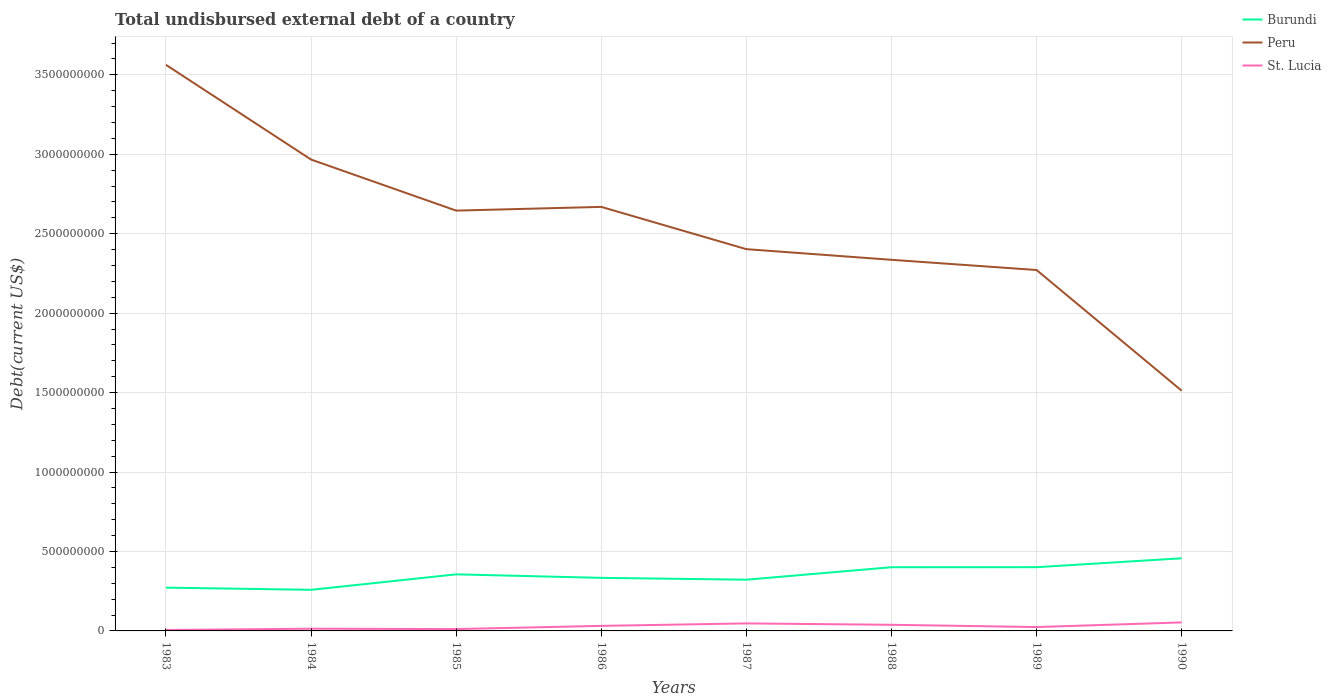How many different coloured lines are there?
Offer a very short reply. 3. Does the line corresponding to Peru intersect with the line corresponding to St. Lucia?
Your answer should be very brief. No. Across all years, what is the maximum total undisbursed external debt in Peru?
Give a very brief answer. 1.51e+09. What is the total total undisbursed external debt in Peru in the graph?
Offer a very short reply. 3.33e+08. What is the difference between the highest and the second highest total undisbursed external debt in St. Lucia?
Provide a short and direct response. 4.74e+07. How many lines are there?
Your response must be concise. 3. How many years are there in the graph?
Your answer should be compact. 8. Does the graph contain grids?
Offer a very short reply. Yes. Where does the legend appear in the graph?
Make the answer very short. Top right. What is the title of the graph?
Offer a very short reply. Total undisbursed external debt of a country. What is the label or title of the X-axis?
Provide a short and direct response. Years. What is the label or title of the Y-axis?
Ensure brevity in your answer.  Debt(current US$). What is the Debt(current US$) in Burundi in 1983?
Provide a short and direct response. 2.72e+08. What is the Debt(current US$) of Peru in 1983?
Your answer should be compact. 3.56e+09. What is the Debt(current US$) in St. Lucia in 1983?
Provide a succinct answer. 6.08e+06. What is the Debt(current US$) of Burundi in 1984?
Your answer should be very brief. 2.59e+08. What is the Debt(current US$) of Peru in 1984?
Give a very brief answer. 2.97e+09. What is the Debt(current US$) of St. Lucia in 1984?
Your answer should be very brief. 1.39e+07. What is the Debt(current US$) of Burundi in 1985?
Give a very brief answer. 3.56e+08. What is the Debt(current US$) in Peru in 1985?
Your response must be concise. 2.65e+09. What is the Debt(current US$) of St. Lucia in 1985?
Provide a short and direct response. 1.16e+07. What is the Debt(current US$) of Burundi in 1986?
Provide a succinct answer. 3.34e+08. What is the Debt(current US$) in Peru in 1986?
Keep it short and to the point. 2.67e+09. What is the Debt(current US$) of St. Lucia in 1986?
Keep it short and to the point. 3.18e+07. What is the Debt(current US$) in Burundi in 1987?
Offer a very short reply. 3.22e+08. What is the Debt(current US$) of Peru in 1987?
Your response must be concise. 2.40e+09. What is the Debt(current US$) of St. Lucia in 1987?
Offer a very short reply. 4.73e+07. What is the Debt(current US$) of Burundi in 1988?
Offer a terse response. 4.01e+08. What is the Debt(current US$) in Peru in 1988?
Your response must be concise. 2.34e+09. What is the Debt(current US$) in St. Lucia in 1988?
Your response must be concise. 3.86e+07. What is the Debt(current US$) of Burundi in 1989?
Provide a short and direct response. 4.01e+08. What is the Debt(current US$) of Peru in 1989?
Give a very brief answer. 2.27e+09. What is the Debt(current US$) in St. Lucia in 1989?
Your answer should be very brief. 2.44e+07. What is the Debt(current US$) of Burundi in 1990?
Make the answer very short. 4.57e+08. What is the Debt(current US$) of Peru in 1990?
Your answer should be compact. 1.51e+09. What is the Debt(current US$) of St. Lucia in 1990?
Give a very brief answer. 5.35e+07. Across all years, what is the maximum Debt(current US$) in Burundi?
Offer a very short reply. 4.57e+08. Across all years, what is the maximum Debt(current US$) of Peru?
Provide a succinct answer. 3.56e+09. Across all years, what is the maximum Debt(current US$) in St. Lucia?
Keep it short and to the point. 5.35e+07. Across all years, what is the minimum Debt(current US$) in Burundi?
Provide a short and direct response. 2.59e+08. Across all years, what is the minimum Debt(current US$) in Peru?
Provide a succinct answer. 1.51e+09. Across all years, what is the minimum Debt(current US$) in St. Lucia?
Your answer should be compact. 6.08e+06. What is the total Debt(current US$) in Burundi in the graph?
Keep it short and to the point. 2.80e+09. What is the total Debt(current US$) of Peru in the graph?
Ensure brevity in your answer.  2.04e+1. What is the total Debt(current US$) in St. Lucia in the graph?
Make the answer very short. 2.27e+08. What is the difference between the Debt(current US$) in Burundi in 1983 and that in 1984?
Make the answer very short. 1.37e+07. What is the difference between the Debt(current US$) in Peru in 1983 and that in 1984?
Offer a very short reply. 5.96e+08. What is the difference between the Debt(current US$) of St. Lucia in 1983 and that in 1984?
Your response must be concise. -7.85e+06. What is the difference between the Debt(current US$) of Burundi in 1983 and that in 1985?
Your answer should be compact. -8.36e+07. What is the difference between the Debt(current US$) of Peru in 1983 and that in 1985?
Ensure brevity in your answer.  9.18e+08. What is the difference between the Debt(current US$) in St. Lucia in 1983 and that in 1985?
Make the answer very short. -5.56e+06. What is the difference between the Debt(current US$) in Burundi in 1983 and that in 1986?
Your answer should be very brief. -6.16e+07. What is the difference between the Debt(current US$) in Peru in 1983 and that in 1986?
Ensure brevity in your answer.  8.94e+08. What is the difference between the Debt(current US$) of St. Lucia in 1983 and that in 1986?
Your response must be concise. -2.57e+07. What is the difference between the Debt(current US$) of Burundi in 1983 and that in 1987?
Offer a very short reply. -5.00e+07. What is the difference between the Debt(current US$) of Peru in 1983 and that in 1987?
Give a very brief answer. 1.16e+09. What is the difference between the Debt(current US$) in St. Lucia in 1983 and that in 1987?
Offer a very short reply. -4.12e+07. What is the difference between the Debt(current US$) in Burundi in 1983 and that in 1988?
Your answer should be very brief. -1.28e+08. What is the difference between the Debt(current US$) of Peru in 1983 and that in 1988?
Your answer should be very brief. 1.23e+09. What is the difference between the Debt(current US$) in St. Lucia in 1983 and that in 1988?
Ensure brevity in your answer.  -3.25e+07. What is the difference between the Debt(current US$) in Burundi in 1983 and that in 1989?
Offer a very short reply. -1.29e+08. What is the difference between the Debt(current US$) of Peru in 1983 and that in 1989?
Your response must be concise. 1.29e+09. What is the difference between the Debt(current US$) of St. Lucia in 1983 and that in 1989?
Make the answer very short. -1.83e+07. What is the difference between the Debt(current US$) in Burundi in 1983 and that in 1990?
Your answer should be compact. -1.85e+08. What is the difference between the Debt(current US$) in Peru in 1983 and that in 1990?
Provide a succinct answer. 2.05e+09. What is the difference between the Debt(current US$) in St. Lucia in 1983 and that in 1990?
Offer a very short reply. -4.74e+07. What is the difference between the Debt(current US$) of Burundi in 1984 and that in 1985?
Provide a short and direct response. -9.73e+07. What is the difference between the Debt(current US$) of Peru in 1984 and that in 1985?
Offer a terse response. 3.21e+08. What is the difference between the Debt(current US$) of St. Lucia in 1984 and that in 1985?
Provide a short and direct response. 2.29e+06. What is the difference between the Debt(current US$) in Burundi in 1984 and that in 1986?
Give a very brief answer. -7.53e+07. What is the difference between the Debt(current US$) in Peru in 1984 and that in 1986?
Offer a terse response. 2.98e+08. What is the difference between the Debt(current US$) in St. Lucia in 1984 and that in 1986?
Ensure brevity in your answer.  -1.79e+07. What is the difference between the Debt(current US$) of Burundi in 1984 and that in 1987?
Offer a very short reply. -6.37e+07. What is the difference between the Debt(current US$) of Peru in 1984 and that in 1987?
Give a very brief answer. 5.64e+08. What is the difference between the Debt(current US$) in St. Lucia in 1984 and that in 1987?
Make the answer very short. -3.34e+07. What is the difference between the Debt(current US$) in Burundi in 1984 and that in 1988?
Offer a terse response. -1.42e+08. What is the difference between the Debt(current US$) in Peru in 1984 and that in 1988?
Provide a short and direct response. 6.31e+08. What is the difference between the Debt(current US$) of St. Lucia in 1984 and that in 1988?
Keep it short and to the point. -2.46e+07. What is the difference between the Debt(current US$) in Burundi in 1984 and that in 1989?
Your answer should be compact. -1.42e+08. What is the difference between the Debt(current US$) in Peru in 1984 and that in 1989?
Offer a terse response. 6.95e+08. What is the difference between the Debt(current US$) of St. Lucia in 1984 and that in 1989?
Offer a very short reply. -1.04e+07. What is the difference between the Debt(current US$) in Burundi in 1984 and that in 1990?
Make the answer very short. -1.98e+08. What is the difference between the Debt(current US$) in Peru in 1984 and that in 1990?
Your answer should be very brief. 1.45e+09. What is the difference between the Debt(current US$) of St. Lucia in 1984 and that in 1990?
Your response must be concise. -3.96e+07. What is the difference between the Debt(current US$) in Burundi in 1985 and that in 1986?
Provide a succinct answer. 2.20e+07. What is the difference between the Debt(current US$) in Peru in 1985 and that in 1986?
Give a very brief answer. -2.34e+07. What is the difference between the Debt(current US$) of St. Lucia in 1985 and that in 1986?
Offer a very short reply. -2.01e+07. What is the difference between the Debt(current US$) in Burundi in 1985 and that in 1987?
Offer a terse response. 3.36e+07. What is the difference between the Debt(current US$) in Peru in 1985 and that in 1987?
Give a very brief answer. 2.43e+08. What is the difference between the Debt(current US$) in St. Lucia in 1985 and that in 1987?
Keep it short and to the point. -3.57e+07. What is the difference between the Debt(current US$) in Burundi in 1985 and that in 1988?
Provide a succinct answer. -4.48e+07. What is the difference between the Debt(current US$) of Peru in 1985 and that in 1988?
Provide a short and direct response. 3.10e+08. What is the difference between the Debt(current US$) in St. Lucia in 1985 and that in 1988?
Make the answer very short. -2.69e+07. What is the difference between the Debt(current US$) in Burundi in 1985 and that in 1989?
Ensure brevity in your answer.  -4.51e+07. What is the difference between the Debt(current US$) of Peru in 1985 and that in 1989?
Provide a succinct answer. 3.74e+08. What is the difference between the Debt(current US$) of St. Lucia in 1985 and that in 1989?
Your answer should be very brief. -1.27e+07. What is the difference between the Debt(current US$) of Burundi in 1985 and that in 1990?
Provide a short and direct response. -1.01e+08. What is the difference between the Debt(current US$) of Peru in 1985 and that in 1990?
Your response must be concise. 1.13e+09. What is the difference between the Debt(current US$) in St. Lucia in 1985 and that in 1990?
Offer a terse response. -4.19e+07. What is the difference between the Debt(current US$) in Burundi in 1986 and that in 1987?
Your response must be concise. 1.16e+07. What is the difference between the Debt(current US$) in Peru in 1986 and that in 1987?
Keep it short and to the point. 2.66e+08. What is the difference between the Debt(current US$) of St. Lucia in 1986 and that in 1987?
Provide a succinct answer. -1.55e+07. What is the difference between the Debt(current US$) of Burundi in 1986 and that in 1988?
Your answer should be very brief. -6.68e+07. What is the difference between the Debt(current US$) in Peru in 1986 and that in 1988?
Keep it short and to the point. 3.33e+08. What is the difference between the Debt(current US$) of St. Lucia in 1986 and that in 1988?
Provide a short and direct response. -6.78e+06. What is the difference between the Debt(current US$) in Burundi in 1986 and that in 1989?
Offer a terse response. -6.71e+07. What is the difference between the Debt(current US$) in Peru in 1986 and that in 1989?
Your answer should be very brief. 3.97e+08. What is the difference between the Debt(current US$) in St. Lucia in 1986 and that in 1989?
Your answer should be compact. 7.41e+06. What is the difference between the Debt(current US$) in Burundi in 1986 and that in 1990?
Your response must be concise. -1.23e+08. What is the difference between the Debt(current US$) in Peru in 1986 and that in 1990?
Provide a succinct answer. 1.16e+09. What is the difference between the Debt(current US$) of St. Lucia in 1986 and that in 1990?
Your answer should be very brief. -2.17e+07. What is the difference between the Debt(current US$) in Burundi in 1987 and that in 1988?
Make the answer very short. -7.84e+07. What is the difference between the Debt(current US$) of Peru in 1987 and that in 1988?
Provide a short and direct response. 6.70e+07. What is the difference between the Debt(current US$) of St. Lucia in 1987 and that in 1988?
Give a very brief answer. 8.75e+06. What is the difference between the Debt(current US$) of Burundi in 1987 and that in 1989?
Offer a very short reply. -7.87e+07. What is the difference between the Debt(current US$) in Peru in 1987 and that in 1989?
Ensure brevity in your answer.  1.31e+08. What is the difference between the Debt(current US$) of St. Lucia in 1987 and that in 1989?
Your answer should be compact. 2.29e+07. What is the difference between the Debt(current US$) of Burundi in 1987 and that in 1990?
Offer a very short reply. -1.35e+08. What is the difference between the Debt(current US$) of Peru in 1987 and that in 1990?
Give a very brief answer. 8.91e+08. What is the difference between the Debt(current US$) in St. Lucia in 1987 and that in 1990?
Your answer should be very brief. -6.20e+06. What is the difference between the Debt(current US$) in Burundi in 1988 and that in 1989?
Offer a terse response. -3.04e+05. What is the difference between the Debt(current US$) in Peru in 1988 and that in 1989?
Make the answer very short. 6.43e+07. What is the difference between the Debt(current US$) in St. Lucia in 1988 and that in 1989?
Your answer should be very brief. 1.42e+07. What is the difference between the Debt(current US$) in Burundi in 1988 and that in 1990?
Provide a short and direct response. -5.63e+07. What is the difference between the Debt(current US$) in Peru in 1988 and that in 1990?
Provide a short and direct response. 8.24e+08. What is the difference between the Debt(current US$) of St. Lucia in 1988 and that in 1990?
Ensure brevity in your answer.  -1.50e+07. What is the difference between the Debt(current US$) of Burundi in 1989 and that in 1990?
Offer a terse response. -5.60e+07. What is the difference between the Debt(current US$) in Peru in 1989 and that in 1990?
Ensure brevity in your answer.  7.60e+08. What is the difference between the Debt(current US$) in St. Lucia in 1989 and that in 1990?
Provide a short and direct response. -2.91e+07. What is the difference between the Debt(current US$) in Burundi in 1983 and the Debt(current US$) in Peru in 1984?
Make the answer very short. -2.69e+09. What is the difference between the Debt(current US$) of Burundi in 1983 and the Debt(current US$) of St. Lucia in 1984?
Your response must be concise. 2.59e+08. What is the difference between the Debt(current US$) in Peru in 1983 and the Debt(current US$) in St. Lucia in 1984?
Your response must be concise. 3.55e+09. What is the difference between the Debt(current US$) of Burundi in 1983 and the Debt(current US$) of Peru in 1985?
Your response must be concise. -2.37e+09. What is the difference between the Debt(current US$) of Burundi in 1983 and the Debt(current US$) of St. Lucia in 1985?
Your answer should be very brief. 2.61e+08. What is the difference between the Debt(current US$) of Peru in 1983 and the Debt(current US$) of St. Lucia in 1985?
Provide a succinct answer. 3.55e+09. What is the difference between the Debt(current US$) in Burundi in 1983 and the Debt(current US$) in Peru in 1986?
Offer a terse response. -2.40e+09. What is the difference between the Debt(current US$) in Burundi in 1983 and the Debt(current US$) in St. Lucia in 1986?
Make the answer very short. 2.41e+08. What is the difference between the Debt(current US$) of Peru in 1983 and the Debt(current US$) of St. Lucia in 1986?
Provide a short and direct response. 3.53e+09. What is the difference between the Debt(current US$) in Burundi in 1983 and the Debt(current US$) in Peru in 1987?
Your answer should be compact. -2.13e+09. What is the difference between the Debt(current US$) of Burundi in 1983 and the Debt(current US$) of St. Lucia in 1987?
Provide a short and direct response. 2.25e+08. What is the difference between the Debt(current US$) of Peru in 1983 and the Debt(current US$) of St. Lucia in 1987?
Offer a terse response. 3.52e+09. What is the difference between the Debt(current US$) of Burundi in 1983 and the Debt(current US$) of Peru in 1988?
Offer a very short reply. -2.06e+09. What is the difference between the Debt(current US$) of Burundi in 1983 and the Debt(current US$) of St. Lucia in 1988?
Offer a terse response. 2.34e+08. What is the difference between the Debt(current US$) of Peru in 1983 and the Debt(current US$) of St. Lucia in 1988?
Your answer should be very brief. 3.52e+09. What is the difference between the Debt(current US$) in Burundi in 1983 and the Debt(current US$) in Peru in 1989?
Your answer should be compact. -2.00e+09. What is the difference between the Debt(current US$) of Burundi in 1983 and the Debt(current US$) of St. Lucia in 1989?
Provide a short and direct response. 2.48e+08. What is the difference between the Debt(current US$) in Peru in 1983 and the Debt(current US$) in St. Lucia in 1989?
Make the answer very short. 3.54e+09. What is the difference between the Debt(current US$) in Burundi in 1983 and the Debt(current US$) in Peru in 1990?
Your response must be concise. -1.24e+09. What is the difference between the Debt(current US$) of Burundi in 1983 and the Debt(current US$) of St. Lucia in 1990?
Offer a terse response. 2.19e+08. What is the difference between the Debt(current US$) in Peru in 1983 and the Debt(current US$) in St. Lucia in 1990?
Provide a succinct answer. 3.51e+09. What is the difference between the Debt(current US$) in Burundi in 1984 and the Debt(current US$) in Peru in 1985?
Your response must be concise. -2.39e+09. What is the difference between the Debt(current US$) of Burundi in 1984 and the Debt(current US$) of St. Lucia in 1985?
Keep it short and to the point. 2.47e+08. What is the difference between the Debt(current US$) of Peru in 1984 and the Debt(current US$) of St. Lucia in 1985?
Keep it short and to the point. 2.96e+09. What is the difference between the Debt(current US$) in Burundi in 1984 and the Debt(current US$) in Peru in 1986?
Your answer should be compact. -2.41e+09. What is the difference between the Debt(current US$) of Burundi in 1984 and the Debt(current US$) of St. Lucia in 1986?
Give a very brief answer. 2.27e+08. What is the difference between the Debt(current US$) in Peru in 1984 and the Debt(current US$) in St. Lucia in 1986?
Your answer should be compact. 2.93e+09. What is the difference between the Debt(current US$) of Burundi in 1984 and the Debt(current US$) of Peru in 1987?
Your answer should be very brief. -2.14e+09. What is the difference between the Debt(current US$) in Burundi in 1984 and the Debt(current US$) in St. Lucia in 1987?
Your answer should be compact. 2.11e+08. What is the difference between the Debt(current US$) of Peru in 1984 and the Debt(current US$) of St. Lucia in 1987?
Offer a very short reply. 2.92e+09. What is the difference between the Debt(current US$) in Burundi in 1984 and the Debt(current US$) in Peru in 1988?
Give a very brief answer. -2.08e+09. What is the difference between the Debt(current US$) of Burundi in 1984 and the Debt(current US$) of St. Lucia in 1988?
Your response must be concise. 2.20e+08. What is the difference between the Debt(current US$) of Peru in 1984 and the Debt(current US$) of St. Lucia in 1988?
Provide a short and direct response. 2.93e+09. What is the difference between the Debt(current US$) of Burundi in 1984 and the Debt(current US$) of Peru in 1989?
Your response must be concise. -2.01e+09. What is the difference between the Debt(current US$) of Burundi in 1984 and the Debt(current US$) of St. Lucia in 1989?
Offer a terse response. 2.34e+08. What is the difference between the Debt(current US$) of Peru in 1984 and the Debt(current US$) of St. Lucia in 1989?
Your response must be concise. 2.94e+09. What is the difference between the Debt(current US$) in Burundi in 1984 and the Debt(current US$) in Peru in 1990?
Your answer should be compact. -1.25e+09. What is the difference between the Debt(current US$) in Burundi in 1984 and the Debt(current US$) in St. Lucia in 1990?
Keep it short and to the point. 2.05e+08. What is the difference between the Debt(current US$) in Peru in 1984 and the Debt(current US$) in St. Lucia in 1990?
Provide a succinct answer. 2.91e+09. What is the difference between the Debt(current US$) of Burundi in 1985 and the Debt(current US$) of Peru in 1986?
Provide a short and direct response. -2.31e+09. What is the difference between the Debt(current US$) of Burundi in 1985 and the Debt(current US$) of St. Lucia in 1986?
Provide a short and direct response. 3.24e+08. What is the difference between the Debt(current US$) of Peru in 1985 and the Debt(current US$) of St. Lucia in 1986?
Give a very brief answer. 2.61e+09. What is the difference between the Debt(current US$) of Burundi in 1985 and the Debt(current US$) of Peru in 1987?
Make the answer very short. -2.05e+09. What is the difference between the Debt(current US$) of Burundi in 1985 and the Debt(current US$) of St. Lucia in 1987?
Your response must be concise. 3.09e+08. What is the difference between the Debt(current US$) in Peru in 1985 and the Debt(current US$) in St. Lucia in 1987?
Give a very brief answer. 2.60e+09. What is the difference between the Debt(current US$) of Burundi in 1985 and the Debt(current US$) of Peru in 1988?
Provide a succinct answer. -1.98e+09. What is the difference between the Debt(current US$) in Burundi in 1985 and the Debt(current US$) in St. Lucia in 1988?
Provide a succinct answer. 3.17e+08. What is the difference between the Debt(current US$) of Peru in 1985 and the Debt(current US$) of St. Lucia in 1988?
Your answer should be very brief. 2.61e+09. What is the difference between the Debt(current US$) of Burundi in 1985 and the Debt(current US$) of Peru in 1989?
Provide a succinct answer. -1.92e+09. What is the difference between the Debt(current US$) of Burundi in 1985 and the Debt(current US$) of St. Lucia in 1989?
Provide a succinct answer. 3.32e+08. What is the difference between the Debt(current US$) in Peru in 1985 and the Debt(current US$) in St. Lucia in 1989?
Provide a succinct answer. 2.62e+09. What is the difference between the Debt(current US$) of Burundi in 1985 and the Debt(current US$) of Peru in 1990?
Your response must be concise. -1.16e+09. What is the difference between the Debt(current US$) in Burundi in 1985 and the Debt(current US$) in St. Lucia in 1990?
Provide a short and direct response. 3.03e+08. What is the difference between the Debt(current US$) of Peru in 1985 and the Debt(current US$) of St. Lucia in 1990?
Make the answer very short. 2.59e+09. What is the difference between the Debt(current US$) of Burundi in 1986 and the Debt(current US$) of Peru in 1987?
Make the answer very short. -2.07e+09. What is the difference between the Debt(current US$) in Burundi in 1986 and the Debt(current US$) in St. Lucia in 1987?
Make the answer very short. 2.87e+08. What is the difference between the Debt(current US$) in Peru in 1986 and the Debt(current US$) in St. Lucia in 1987?
Your answer should be very brief. 2.62e+09. What is the difference between the Debt(current US$) in Burundi in 1986 and the Debt(current US$) in Peru in 1988?
Your response must be concise. -2.00e+09. What is the difference between the Debt(current US$) in Burundi in 1986 and the Debt(current US$) in St. Lucia in 1988?
Keep it short and to the point. 2.95e+08. What is the difference between the Debt(current US$) in Peru in 1986 and the Debt(current US$) in St. Lucia in 1988?
Make the answer very short. 2.63e+09. What is the difference between the Debt(current US$) of Burundi in 1986 and the Debt(current US$) of Peru in 1989?
Your answer should be compact. -1.94e+09. What is the difference between the Debt(current US$) in Burundi in 1986 and the Debt(current US$) in St. Lucia in 1989?
Offer a very short reply. 3.10e+08. What is the difference between the Debt(current US$) in Peru in 1986 and the Debt(current US$) in St. Lucia in 1989?
Your response must be concise. 2.64e+09. What is the difference between the Debt(current US$) of Burundi in 1986 and the Debt(current US$) of Peru in 1990?
Provide a succinct answer. -1.18e+09. What is the difference between the Debt(current US$) of Burundi in 1986 and the Debt(current US$) of St. Lucia in 1990?
Keep it short and to the point. 2.80e+08. What is the difference between the Debt(current US$) in Peru in 1986 and the Debt(current US$) in St. Lucia in 1990?
Offer a terse response. 2.62e+09. What is the difference between the Debt(current US$) in Burundi in 1987 and the Debt(current US$) in Peru in 1988?
Your response must be concise. -2.01e+09. What is the difference between the Debt(current US$) in Burundi in 1987 and the Debt(current US$) in St. Lucia in 1988?
Your response must be concise. 2.84e+08. What is the difference between the Debt(current US$) of Peru in 1987 and the Debt(current US$) of St. Lucia in 1988?
Provide a succinct answer. 2.36e+09. What is the difference between the Debt(current US$) of Burundi in 1987 and the Debt(current US$) of Peru in 1989?
Provide a short and direct response. -1.95e+09. What is the difference between the Debt(current US$) in Burundi in 1987 and the Debt(current US$) in St. Lucia in 1989?
Provide a short and direct response. 2.98e+08. What is the difference between the Debt(current US$) of Peru in 1987 and the Debt(current US$) of St. Lucia in 1989?
Offer a terse response. 2.38e+09. What is the difference between the Debt(current US$) of Burundi in 1987 and the Debt(current US$) of Peru in 1990?
Your response must be concise. -1.19e+09. What is the difference between the Debt(current US$) in Burundi in 1987 and the Debt(current US$) in St. Lucia in 1990?
Ensure brevity in your answer.  2.69e+08. What is the difference between the Debt(current US$) in Peru in 1987 and the Debt(current US$) in St. Lucia in 1990?
Your answer should be compact. 2.35e+09. What is the difference between the Debt(current US$) of Burundi in 1988 and the Debt(current US$) of Peru in 1989?
Give a very brief answer. -1.87e+09. What is the difference between the Debt(current US$) of Burundi in 1988 and the Debt(current US$) of St. Lucia in 1989?
Offer a very short reply. 3.76e+08. What is the difference between the Debt(current US$) of Peru in 1988 and the Debt(current US$) of St. Lucia in 1989?
Provide a short and direct response. 2.31e+09. What is the difference between the Debt(current US$) in Burundi in 1988 and the Debt(current US$) in Peru in 1990?
Your answer should be compact. -1.11e+09. What is the difference between the Debt(current US$) of Burundi in 1988 and the Debt(current US$) of St. Lucia in 1990?
Your answer should be compact. 3.47e+08. What is the difference between the Debt(current US$) in Peru in 1988 and the Debt(current US$) in St. Lucia in 1990?
Keep it short and to the point. 2.28e+09. What is the difference between the Debt(current US$) in Burundi in 1989 and the Debt(current US$) in Peru in 1990?
Provide a succinct answer. -1.11e+09. What is the difference between the Debt(current US$) of Burundi in 1989 and the Debt(current US$) of St. Lucia in 1990?
Your answer should be compact. 3.48e+08. What is the difference between the Debt(current US$) in Peru in 1989 and the Debt(current US$) in St. Lucia in 1990?
Keep it short and to the point. 2.22e+09. What is the average Debt(current US$) in Burundi per year?
Your response must be concise. 3.50e+08. What is the average Debt(current US$) in Peru per year?
Your answer should be compact. 2.55e+09. What is the average Debt(current US$) of St. Lucia per year?
Provide a succinct answer. 2.84e+07. In the year 1983, what is the difference between the Debt(current US$) of Burundi and Debt(current US$) of Peru?
Keep it short and to the point. -3.29e+09. In the year 1983, what is the difference between the Debt(current US$) of Burundi and Debt(current US$) of St. Lucia?
Give a very brief answer. 2.66e+08. In the year 1983, what is the difference between the Debt(current US$) of Peru and Debt(current US$) of St. Lucia?
Your answer should be compact. 3.56e+09. In the year 1984, what is the difference between the Debt(current US$) of Burundi and Debt(current US$) of Peru?
Your answer should be very brief. -2.71e+09. In the year 1984, what is the difference between the Debt(current US$) of Burundi and Debt(current US$) of St. Lucia?
Offer a very short reply. 2.45e+08. In the year 1984, what is the difference between the Debt(current US$) in Peru and Debt(current US$) in St. Lucia?
Give a very brief answer. 2.95e+09. In the year 1985, what is the difference between the Debt(current US$) of Burundi and Debt(current US$) of Peru?
Give a very brief answer. -2.29e+09. In the year 1985, what is the difference between the Debt(current US$) in Burundi and Debt(current US$) in St. Lucia?
Your answer should be very brief. 3.44e+08. In the year 1985, what is the difference between the Debt(current US$) in Peru and Debt(current US$) in St. Lucia?
Make the answer very short. 2.63e+09. In the year 1986, what is the difference between the Debt(current US$) in Burundi and Debt(current US$) in Peru?
Ensure brevity in your answer.  -2.33e+09. In the year 1986, what is the difference between the Debt(current US$) in Burundi and Debt(current US$) in St. Lucia?
Your answer should be compact. 3.02e+08. In the year 1986, what is the difference between the Debt(current US$) of Peru and Debt(current US$) of St. Lucia?
Your answer should be very brief. 2.64e+09. In the year 1987, what is the difference between the Debt(current US$) in Burundi and Debt(current US$) in Peru?
Ensure brevity in your answer.  -2.08e+09. In the year 1987, what is the difference between the Debt(current US$) in Burundi and Debt(current US$) in St. Lucia?
Your answer should be very brief. 2.75e+08. In the year 1987, what is the difference between the Debt(current US$) of Peru and Debt(current US$) of St. Lucia?
Make the answer very short. 2.36e+09. In the year 1988, what is the difference between the Debt(current US$) of Burundi and Debt(current US$) of Peru?
Keep it short and to the point. -1.93e+09. In the year 1988, what is the difference between the Debt(current US$) in Burundi and Debt(current US$) in St. Lucia?
Your answer should be very brief. 3.62e+08. In the year 1988, what is the difference between the Debt(current US$) in Peru and Debt(current US$) in St. Lucia?
Provide a short and direct response. 2.30e+09. In the year 1989, what is the difference between the Debt(current US$) in Burundi and Debt(current US$) in Peru?
Your response must be concise. -1.87e+09. In the year 1989, what is the difference between the Debt(current US$) of Burundi and Debt(current US$) of St. Lucia?
Offer a very short reply. 3.77e+08. In the year 1989, what is the difference between the Debt(current US$) in Peru and Debt(current US$) in St. Lucia?
Provide a succinct answer. 2.25e+09. In the year 1990, what is the difference between the Debt(current US$) in Burundi and Debt(current US$) in Peru?
Your answer should be very brief. -1.05e+09. In the year 1990, what is the difference between the Debt(current US$) of Burundi and Debt(current US$) of St. Lucia?
Your response must be concise. 4.04e+08. In the year 1990, what is the difference between the Debt(current US$) of Peru and Debt(current US$) of St. Lucia?
Make the answer very short. 1.46e+09. What is the ratio of the Debt(current US$) in Burundi in 1983 to that in 1984?
Your answer should be very brief. 1.05. What is the ratio of the Debt(current US$) in Peru in 1983 to that in 1984?
Make the answer very short. 1.2. What is the ratio of the Debt(current US$) of St. Lucia in 1983 to that in 1984?
Your response must be concise. 0.44. What is the ratio of the Debt(current US$) of Burundi in 1983 to that in 1985?
Your answer should be compact. 0.77. What is the ratio of the Debt(current US$) in Peru in 1983 to that in 1985?
Your answer should be compact. 1.35. What is the ratio of the Debt(current US$) of St. Lucia in 1983 to that in 1985?
Your response must be concise. 0.52. What is the ratio of the Debt(current US$) of Burundi in 1983 to that in 1986?
Your response must be concise. 0.82. What is the ratio of the Debt(current US$) in Peru in 1983 to that in 1986?
Make the answer very short. 1.33. What is the ratio of the Debt(current US$) of St. Lucia in 1983 to that in 1986?
Your response must be concise. 0.19. What is the ratio of the Debt(current US$) in Burundi in 1983 to that in 1987?
Your answer should be very brief. 0.84. What is the ratio of the Debt(current US$) in Peru in 1983 to that in 1987?
Offer a terse response. 1.48. What is the ratio of the Debt(current US$) in St. Lucia in 1983 to that in 1987?
Your answer should be compact. 0.13. What is the ratio of the Debt(current US$) of Burundi in 1983 to that in 1988?
Make the answer very short. 0.68. What is the ratio of the Debt(current US$) of Peru in 1983 to that in 1988?
Give a very brief answer. 1.53. What is the ratio of the Debt(current US$) of St. Lucia in 1983 to that in 1988?
Make the answer very short. 0.16. What is the ratio of the Debt(current US$) in Burundi in 1983 to that in 1989?
Give a very brief answer. 0.68. What is the ratio of the Debt(current US$) in Peru in 1983 to that in 1989?
Ensure brevity in your answer.  1.57. What is the ratio of the Debt(current US$) of St. Lucia in 1983 to that in 1989?
Your answer should be very brief. 0.25. What is the ratio of the Debt(current US$) in Burundi in 1983 to that in 1990?
Ensure brevity in your answer.  0.6. What is the ratio of the Debt(current US$) in Peru in 1983 to that in 1990?
Offer a very short reply. 2.36. What is the ratio of the Debt(current US$) of St. Lucia in 1983 to that in 1990?
Make the answer very short. 0.11. What is the ratio of the Debt(current US$) of Burundi in 1984 to that in 1985?
Offer a very short reply. 0.73. What is the ratio of the Debt(current US$) of Peru in 1984 to that in 1985?
Your response must be concise. 1.12. What is the ratio of the Debt(current US$) of St. Lucia in 1984 to that in 1985?
Offer a terse response. 1.2. What is the ratio of the Debt(current US$) in Burundi in 1984 to that in 1986?
Keep it short and to the point. 0.77. What is the ratio of the Debt(current US$) of Peru in 1984 to that in 1986?
Your answer should be very brief. 1.11. What is the ratio of the Debt(current US$) of St. Lucia in 1984 to that in 1986?
Give a very brief answer. 0.44. What is the ratio of the Debt(current US$) in Burundi in 1984 to that in 1987?
Your response must be concise. 0.8. What is the ratio of the Debt(current US$) of Peru in 1984 to that in 1987?
Keep it short and to the point. 1.23. What is the ratio of the Debt(current US$) in St. Lucia in 1984 to that in 1987?
Make the answer very short. 0.29. What is the ratio of the Debt(current US$) of Burundi in 1984 to that in 1988?
Provide a short and direct response. 0.65. What is the ratio of the Debt(current US$) of Peru in 1984 to that in 1988?
Provide a succinct answer. 1.27. What is the ratio of the Debt(current US$) in St. Lucia in 1984 to that in 1988?
Make the answer very short. 0.36. What is the ratio of the Debt(current US$) in Burundi in 1984 to that in 1989?
Your answer should be very brief. 0.65. What is the ratio of the Debt(current US$) in Peru in 1984 to that in 1989?
Your answer should be very brief. 1.31. What is the ratio of the Debt(current US$) in St. Lucia in 1984 to that in 1989?
Keep it short and to the point. 0.57. What is the ratio of the Debt(current US$) of Burundi in 1984 to that in 1990?
Provide a short and direct response. 0.57. What is the ratio of the Debt(current US$) in Peru in 1984 to that in 1990?
Offer a terse response. 1.96. What is the ratio of the Debt(current US$) of St. Lucia in 1984 to that in 1990?
Your response must be concise. 0.26. What is the ratio of the Debt(current US$) of Burundi in 1985 to that in 1986?
Your answer should be very brief. 1.07. What is the ratio of the Debt(current US$) in St. Lucia in 1985 to that in 1986?
Keep it short and to the point. 0.37. What is the ratio of the Debt(current US$) in Burundi in 1985 to that in 1987?
Your response must be concise. 1.1. What is the ratio of the Debt(current US$) of Peru in 1985 to that in 1987?
Provide a succinct answer. 1.1. What is the ratio of the Debt(current US$) of St. Lucia in 1985 to that in 1987?
Provide a succinct answer. 0.25. What is the ratio of the Debt(current US$) of Burundi in 1985 to that in 1988?
Offer a terse response. 0.89. What is the ratio of the Debt(current US$) in Peru in 1985 to that in 1988?
Your response must be concise. 1.13. What is the ratio of the Debt(current US$) in St. Lucia in 1985 to that in 1988?
Offer a terse response. 0.3. What is the ratio of the Debt(current US$) of Burundi in 1985 to that in 1989?
Offer a very short reply. 0.89. What is the ratio of the Debt(current US$) in Peru in 1985 to that in 1989?
Give a very brief answer. 1.16. What is the ratio of the Debt(current US$) in St. Lucia in 1985 to that in 1989?
Make the answer very short. 0.48. What is the ratio of the Debt(current US$) of Burundi in 1985 to that in 1990?
Your response must be concise. 0.78. What is the ratio of the Debt(current US$) of Peru in 1985 to that in 1990?
Offer a terse response. 1.75. What is the ratio of the Debt(current US$) of St. Lucia in 1985 to that in 1990?
Make the answer very short. 0.22. What is the ratio of the Debt(current US$) in Burundi in 1986 to that in 1987?
Your answer should be compact. 1.04. What is the ratio of the Debt(current US$) in Peru in 1986 to that in 1987?
Provide a short and direct response. 1.11. What is the ratio of the Debt(current US$) in St. Lucia in 1986 to that in 1987?
Make the answer very short. 0.67. What is the ratio of the Debt(current US$) of Burundi in 1986 to that in 1988?
Provide a succinct answer. 0.83. What is the ratio of the Debt(current US$) of Peru in 1986 to that in 1988?
Provide a succinct answer. 1.14. What is the ratio of the Debt(current US$) in St. Lucia in 1986 to that in 1988?
Provide a succinct answer. 0.82. What is the ratio of the Debt(current US$) of Burundi in 1986 to that in 1989?
Offer a very short reply. 0.83. What is the ratio of the Debt(current US$) in Peru in 1986 to that in 1989?
Provide a succinct answer. 1.17. What is the ratio of the Debt(current US$) of St. Lucia in 1986 to that in 1989?
Provide a short and direct response. 1.3. What is the ratio of the Debt(current US$) of Burundi in 1986 to that in 1990?
Keep it short and to the point. 0.73. What is the ratio of the Debt(current US$) in Peru in 1986 to that in 1990?
Make the answer very short. 1.77. What is the ratio of the Debt(current US$) in St. Lucia in 1986 to that in 1990?
Offer a terse response. 0.59. What is the ratio of the Debt(current US$) in Burundi in 1987 to that in 1988?
Make the answer very short. 0.8. What is the ratio of the Debt(current US$) in Peru in 1987 to that in 1988?
Keep it short and to the point. 1.03. What is the ratio of the Debt(current US$) in St. Lucia in 1987 to that in 1988?
Your answer should be very brief. 1.23. What is the ratio of the Debt(current US$) of Burundi in 1987 to that in 1989?
Give a very brief answer. 0.8. What is the ratio of the Debt(current US$) of Peru in 1987 to that in 1989?
Provide a succinct answer. 1.06. What is the ratio of the Debt(current US$) of St. Lucia in 1987 to that in 1989?
Your answer should be very brief. 1.94. What is the ratio of the Debt(current US$) in Burundi in 1987 to that in 1990?
Provide a succinct answer. 0.71. What is the ratio of the Debt(current US$) of Peru in 1987 to that in 1990?
Make the answer very short. 1.59. What is the ratio of the Debt(current US$) of St. Lucia in 1987 to that in 1990?
Offer a terse response. 0.88. What is the ratio of the Debt(current US$) in Peru in 1988 to that in 1989?
Your response must be concise. 1.03. What is the ratio of the Debt(current US$) in St. Lucia in 1988 to that in 1989?
Your response must be concise. 1.58. What is the ratio of the Debt(current US$) in Burundi in 1988 to that in 1990?
Provide a short and direct response. 0.88. What is the ratio of the Debt(current US$) of Peru in 1988 to that in 1990?
Keep it short and to the point. 1.54. What is the ratio of the Debt(current US$) of St. Lucia in 1988 to that in 1990?
Offer a very short reply. 0.72. What is the ratio of the Debt(current US$) in Burundi in 1989 to that in 1990?
Keep it short and to the point. 0.88. What is the ratio of the Debt(current US$) of Peru in 1989 to that in 1990?
Offer a very short reply. 1.5. What is the ratio of the Debt(current US$) in St. Lucia in 1989 to that in 1990?
Provide a succinct answer. 0.46. What is the difference between the highest and the second highest Debt(current US$) in Burundi?
Offer a terse response. 5.60e+07. What is the difference between the highest and the second highest Debt(current US$) in Peru?
Give a very brief answer. 5.96e+08. What is the difference between the highest and the second highest Debt(current US$) in St. Lucia?
Your answer should be compact. 6.20e+06. What is the difference between the highest and the lowest Debt(current US$) of Burundi?
Your response must be concise. 1.98e+08. What is the difference between the highest and the lowest Debt(current US$) of Peru?
Offer a very short reply. 2.05e+09. What is the difference between the highest and the lowest Debt(current US$) in St. Lucia?
Make the answer very short. 4.74e+07. 